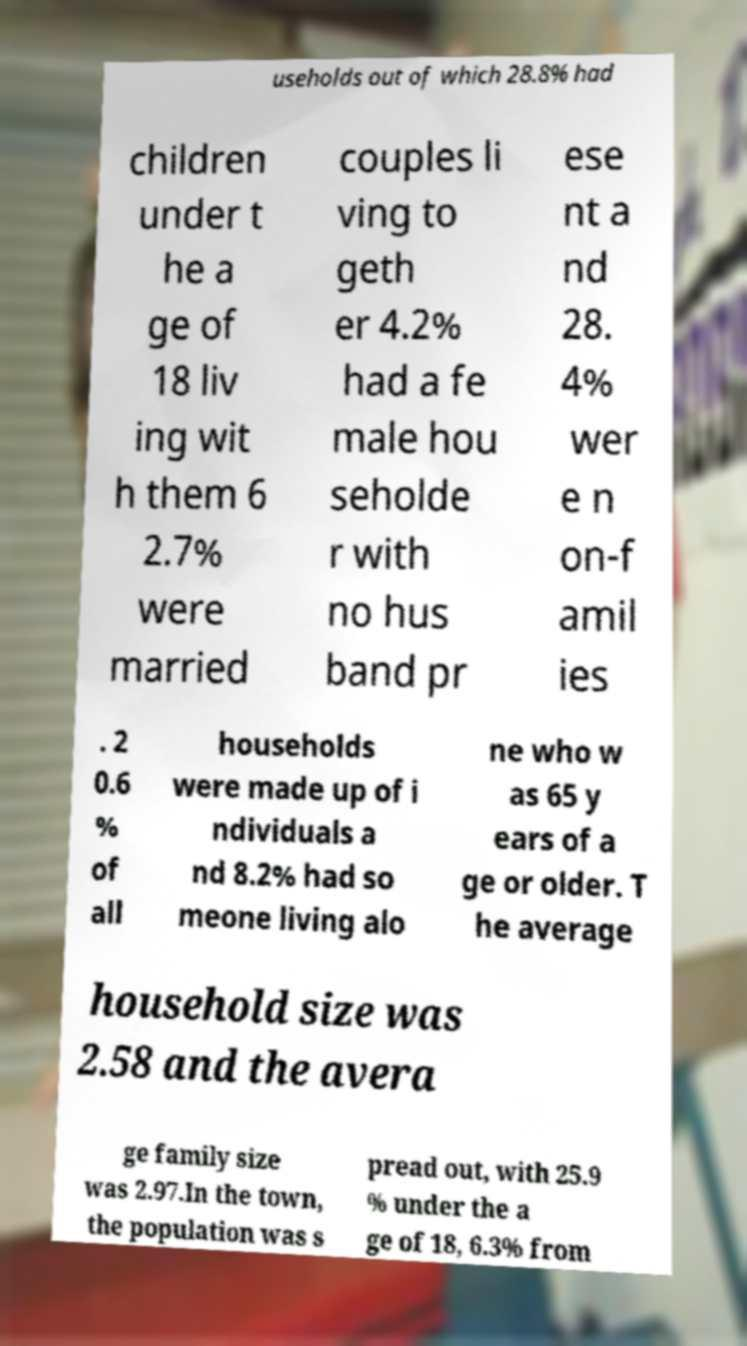What messages or text are displayed in this image? I need them in a readable, typed format. useholds out of which 28.8% had children under t he a ge of 18 liv ing wit h them 6 2.7% were married couples li ving to geth er 4.2% had a fe male hou seholde r with no hus band pr ese nt a nd 28. 4% wer e n on-f amil ies . 2 0.6 % of all households were made up of i ndividuals a nd 8.2% had so meone living alo ne who w as 65 y ears of a ge or older. T he average household size was 2.58 and the avera ge family size was 2.97.In the town, the population was s pread out, with 25.9 % under the a ge of 18, 6.3% from 